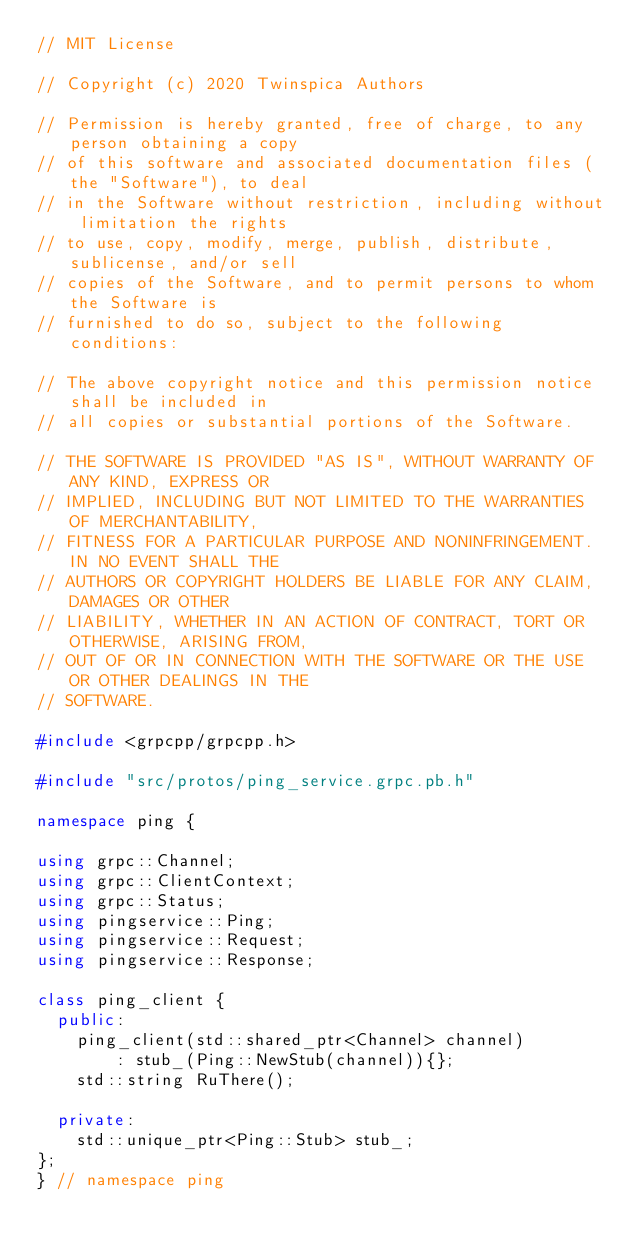<code> <loc_0><loc_0><loc_500><loc_500><_C++_>// MIT License

// Copyright (c) 2020 Twinspica Authors

// Permission is hereby granted, free of charge, to any person obtaining a copy
// of this software and associated documentation files (the "Software"), to deal
// in the Software without restriction, including without limitation the rights
// to use, copy, modify, merge, publish, distribute, sublicense, and/or sell
// copies of the Software, and to permit persons to whom the Software is
// furnished to do so, subject to the following conditions:

// The above copyright notice and this permission notice shall be included in
// all copies or substantial portions of the Software.

// THE SOFTWARE IS PROVIDED "AS IS", WITHOUT WARRANTY OF ANY KIND, EXPRESS OR
// IMPLIED, INCLUDING BUT NOT LIMITED TO THE WARRANTIES OF MERCHANTABILITY,
// FITNESS FOR A PARTICULAR PURPOSE AND NONINFRINGEMENT. IN NO EVENT SHALL THE
// AUTHORS OR COPYRIGHT HOLDERS BE LIABLE FOR ANY CLAIM, DAMAGES OR OTHER
// LIABILITY, WHETHER IN AN ACTION OF CONTRACT, TORT OR OTHERWISE, ARISING FROM,
// OUT OF OR IN CONNECTION WITH THE SOFTWARE OR THE USE OR OTHER DEALINGS IN THE
// SOFTWARE.

#include <grpcpp/grpcpp.h>

#include "src/protos/ping_service.grpc.pb.h"

namespace ping {

using grpc::Channel;
using grpc::ClientContext;
using grpc::Status;
using pingservice::Ping;
using pingservice::Request;
using pingservice::Response;

class ping_client {
  public:
    ping_client(std::shared_ptr<Channel> channel)
        : stub_(Ping::NewStub(channel)){};
    std::string RuThere();

  private:
    std::unique_ptr<Ping::Stub> stub_;
};
} // namespace ping
</code> 